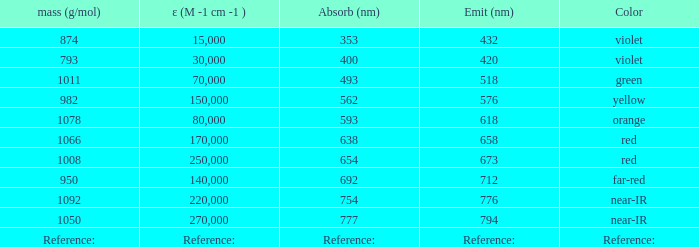Which Emission (in nanometers) that has a molar mass of 1078 g/mol? 618.0. 